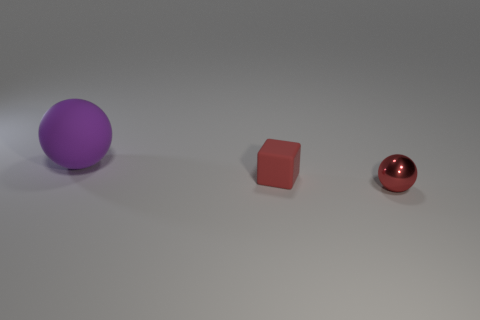Are there any tiny objects that have the same color as the tiny matte block?
Keep it short and to the point. Yes. How many things are large blue shiny balls or spheres that are in front of the purple matte thing?
Provide a succinct answer. 1. There is a thing that is both behind the metal object and right of the big purple rubber object; what material is it made of?
Your answer should be compact. Rubber. Are there any other things that are the same shape as the small rubber object?
Make the answer very short. No. The object that is the same material as the red cube is what color?
Offer a terse response. Purple. How many objects are small gray blocks or tiny cubes?
Your response must be concise. 1. Does the metal object have the same size as the red object that is behind the small red metal ball?
Provide a succinct answer. Yes. What color is the small thing that is in front of the red thing left of the ball that is right of the red cube?
Provide a succinct answer. Red. The big matte object is what color?
Your answer should be very brief. Purple. Are there more big rubber things to the left of the matte sphere than small things in front of the tiny cube?
Your answer should be compact. No. 